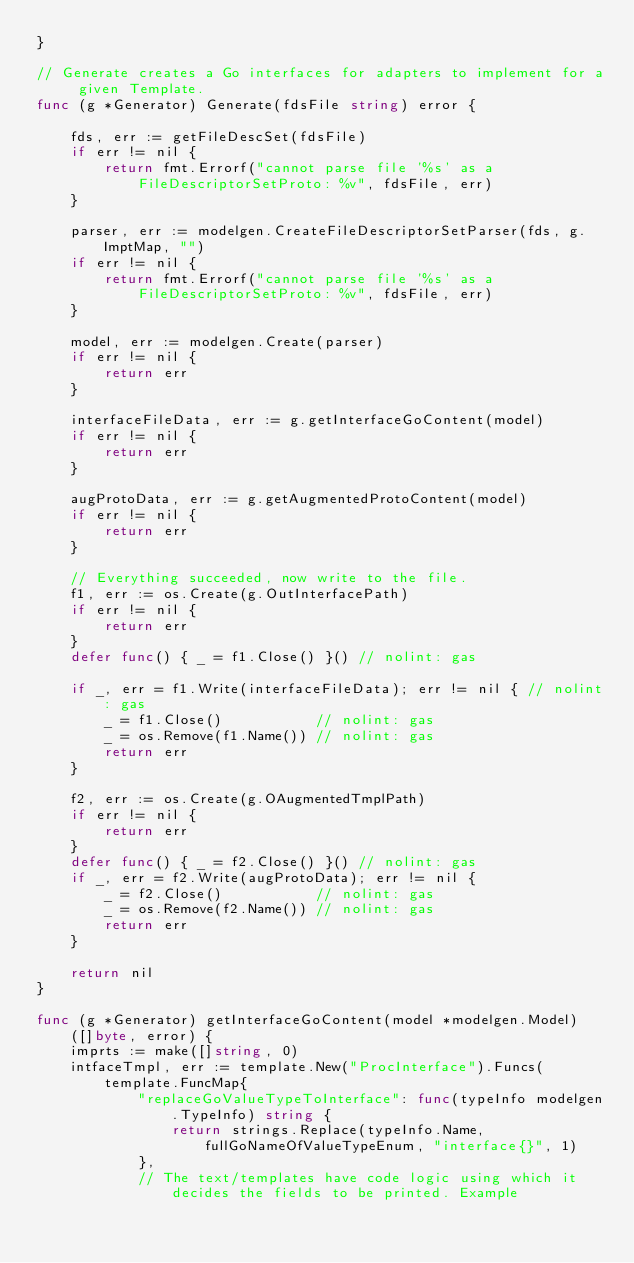Convert code to text. <code><loc_0><loc_0><loc_500><loc_500><_Go_>}

// Generate creates a Go interfaces for adapters to implement for a given Template.
func (g *Generator) Generate(fdsFile string) error {

	fds, err := getFileDescSet(fdsFile)
	if err != nil {
		return fmt.Errorf("cannot parse file '%s' as a FileDescriptorSetProto: %v", fdsFile, err)
	}

	parser, err := modelgen.CreateFileDescriptorSetParser(fds, g.ImptMap, "")
	if err != nil {
		return fmt.Errorf("cannot parse file '%s' as a FileDescriptorSetProto: %v", fdsFile, err)
	}

	model, err := modelgen.Create(parser)
	if err != nil {
		return err
	}

	interfaceFileData, err := g.getInterfaceGoContent(model)
	if err != nil {
		return err
	}

	augProtoData, err := g.getAugmentedProtoContent(model)
	if err != nil {
		return err
	}

	// Everything succeeded, now write to the file.
	f1, err := os.Create(g.OutInterfacePath)
	if err != nil {
		return err
	}
	defer func() { _ = f1.Close() }() // nolint: gas

	if _, err = f1.Write(interfaceFileData); err != nil { // nolint: gas
		_ = f1.Close()           // nolint: gas
		_ = os.Remove(f1.Name()) // nolint: gas
		return err
	}

	f2, err := os.Create(g.OAugmentedTmplPath)
	if err != nil {
		return err
	}
	defer func() { _ = f2.Close() }() // nolint: gas
	if _, err = f2.Write(augProtoData); err != nil {
		_ = f2.Close()           // nolint: gas
		_ = os.Remove(f2.Name()) // nolint: gas
		return err
	}

	return nil
}

func (g *Generator) getInterfaceGoContent(model *modelgen.Model) ([]byte, error) {
	imprts := make([]string, 0)
	intfaceTmpl, err := template.New("ProcInterface").Funcs(
		template.FuncMap{
			"replaceGoValueTypeToInterface": func(typeInfo modelgen.TypeInfo) string {
				return strings.Replace(typeInfo.Name, fullGoNameOfValueTypeEnum, "interface{}", 1)
			},
			// The text/templates have code logic using which it decides the fields to be printed. Example</code> 